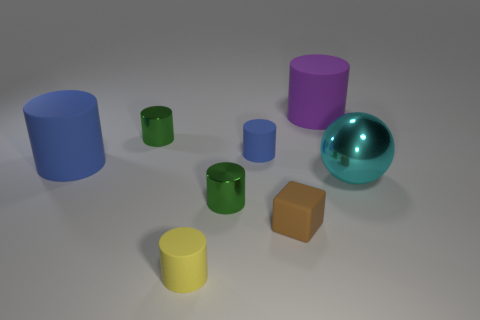Subtract 3 cylinders. How many cylinders are left? 3 Subtract all tiny blue rubber cylinders. How many cylinders are left? 5 Subtract all blue cylinders. How many cylinders are left? 4 Subtract all purple cylinders. Subtract all blue spheres. How many cylinders are left? 5 Add 1 blocks. How many objects exist? 9 Subtract all spheres. How many objects are left? 7 Subtract all large metal blocks. Subtract all big purple cylinders. How many objects are left? 7 Add 5 blue matte things. How many blue matte things are left? 7 Add 7 big things. How many big things exist? 10 Subtract 0 yellow spheres. How many objects are left? 8 